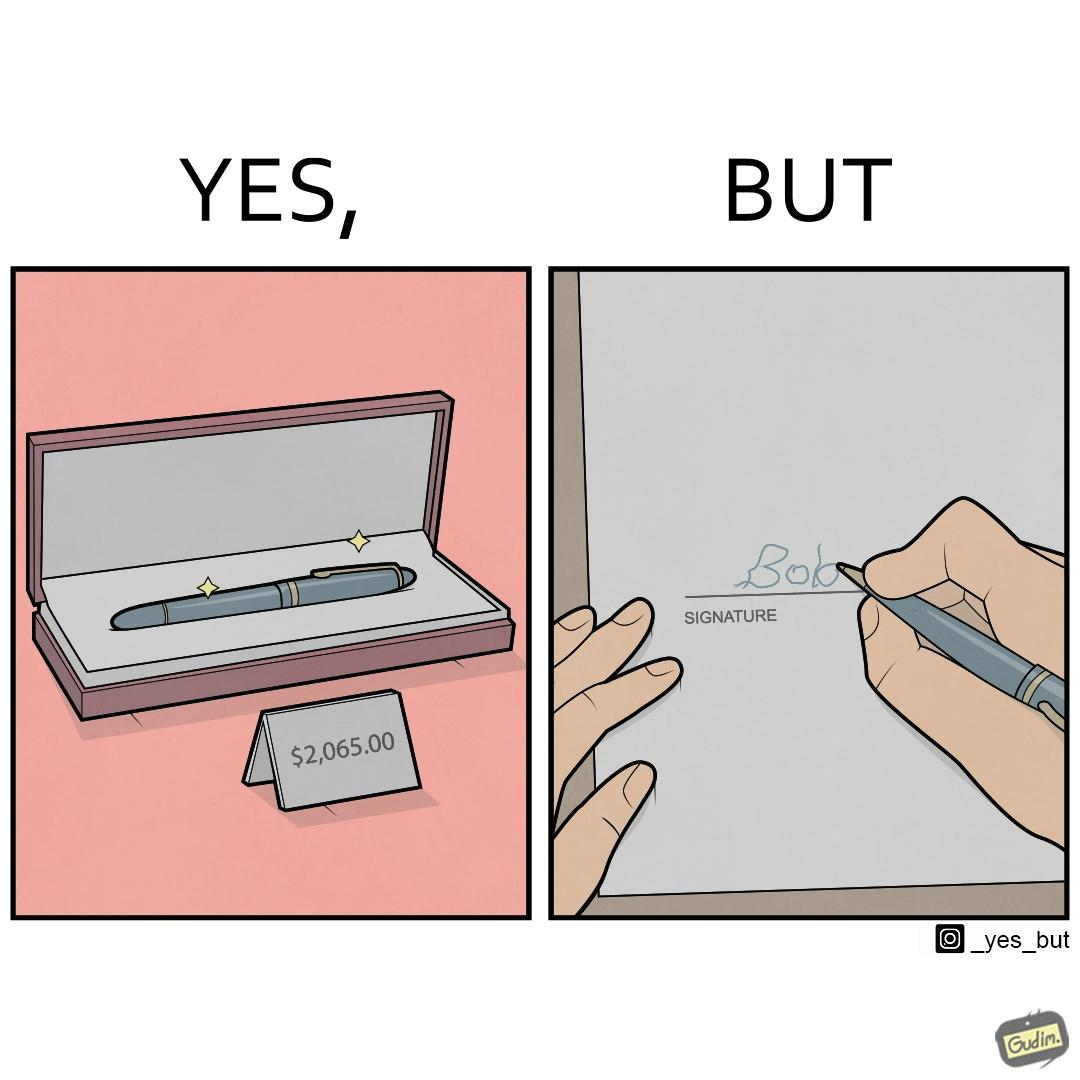Describe the satirical element in this image. The image is ironic, because it conveys the message that even with the costliest of pens people handwriting remains the same 